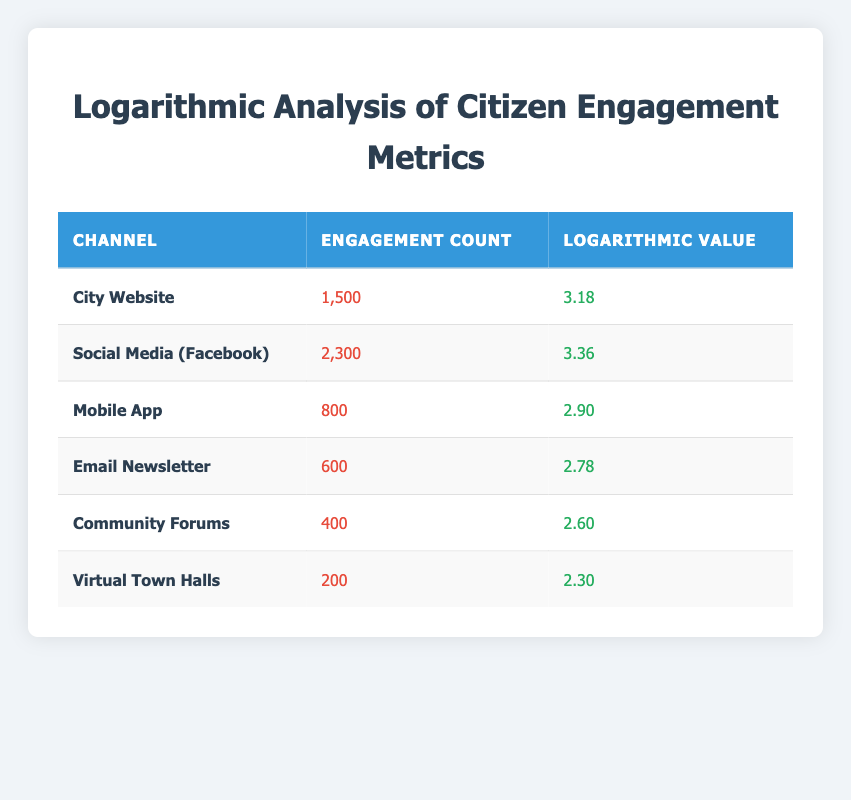What is the engagement count for the City Website? The table shows the engagement count for the City Website listed directly. The engagement count provided is 1,500.
Answer: 1500 Which channel has the highest engagement count? By comparing the engagement counts in the table, Social Media (Facebook) has the highest value at 2,300, which is greater than all other channels.
Answer: Social Media (Facebook) What is the logarithmic value for the Mobile App? The table lists the logarithmic value for Mobile App. It is 2.90 based on the provided data.
Answer: 2.90 Calculate the total engagement count across all channels. Adding up the engagement counts from each channel: 1500 + 2300 + 800 + 600 + 400 + 200 = 5800.
Answer: 5800 Is the engagement count for Virtual Town Halls greater than that of Community Forums? Comparing the engagement counts, Virtual Town Halls has 200 while Community Forums has 400. Since 200 is less than 400, the statement is false.
Answer: No What is the average engagement count across all channels? To calculate the average, sum the engagement counts (5800) and divide by the number of channels (6): 5800 / 6 = 966.67, giving an average engagement count of approximately 966.67.
Answer: 966.67 Which channel has a logarithmic value greater than 3.00? Looking at the logarithmic values in the table, both the City Website (3.18) and Social Media (Facebook) (3.36) have logarithmic values greater than 3.00.
Answer: City Website and Social Media (Facebook) What is the difference between the highest and lowest engagement counts? The highest engagement count is 2300 from Social Media (Facebook), and the lowest is 200 from Virtual Town Halls. The difference is 2300 - 200 = 2100.
Answer: 2100 Are there more than four channels with an engagement count over 1000? Examining the table, there are three channels with engagement counts over 1000: City Website (1500), and Social Media (Facebook) (2300). This is less than four, so the statement is false.
Answer: No 